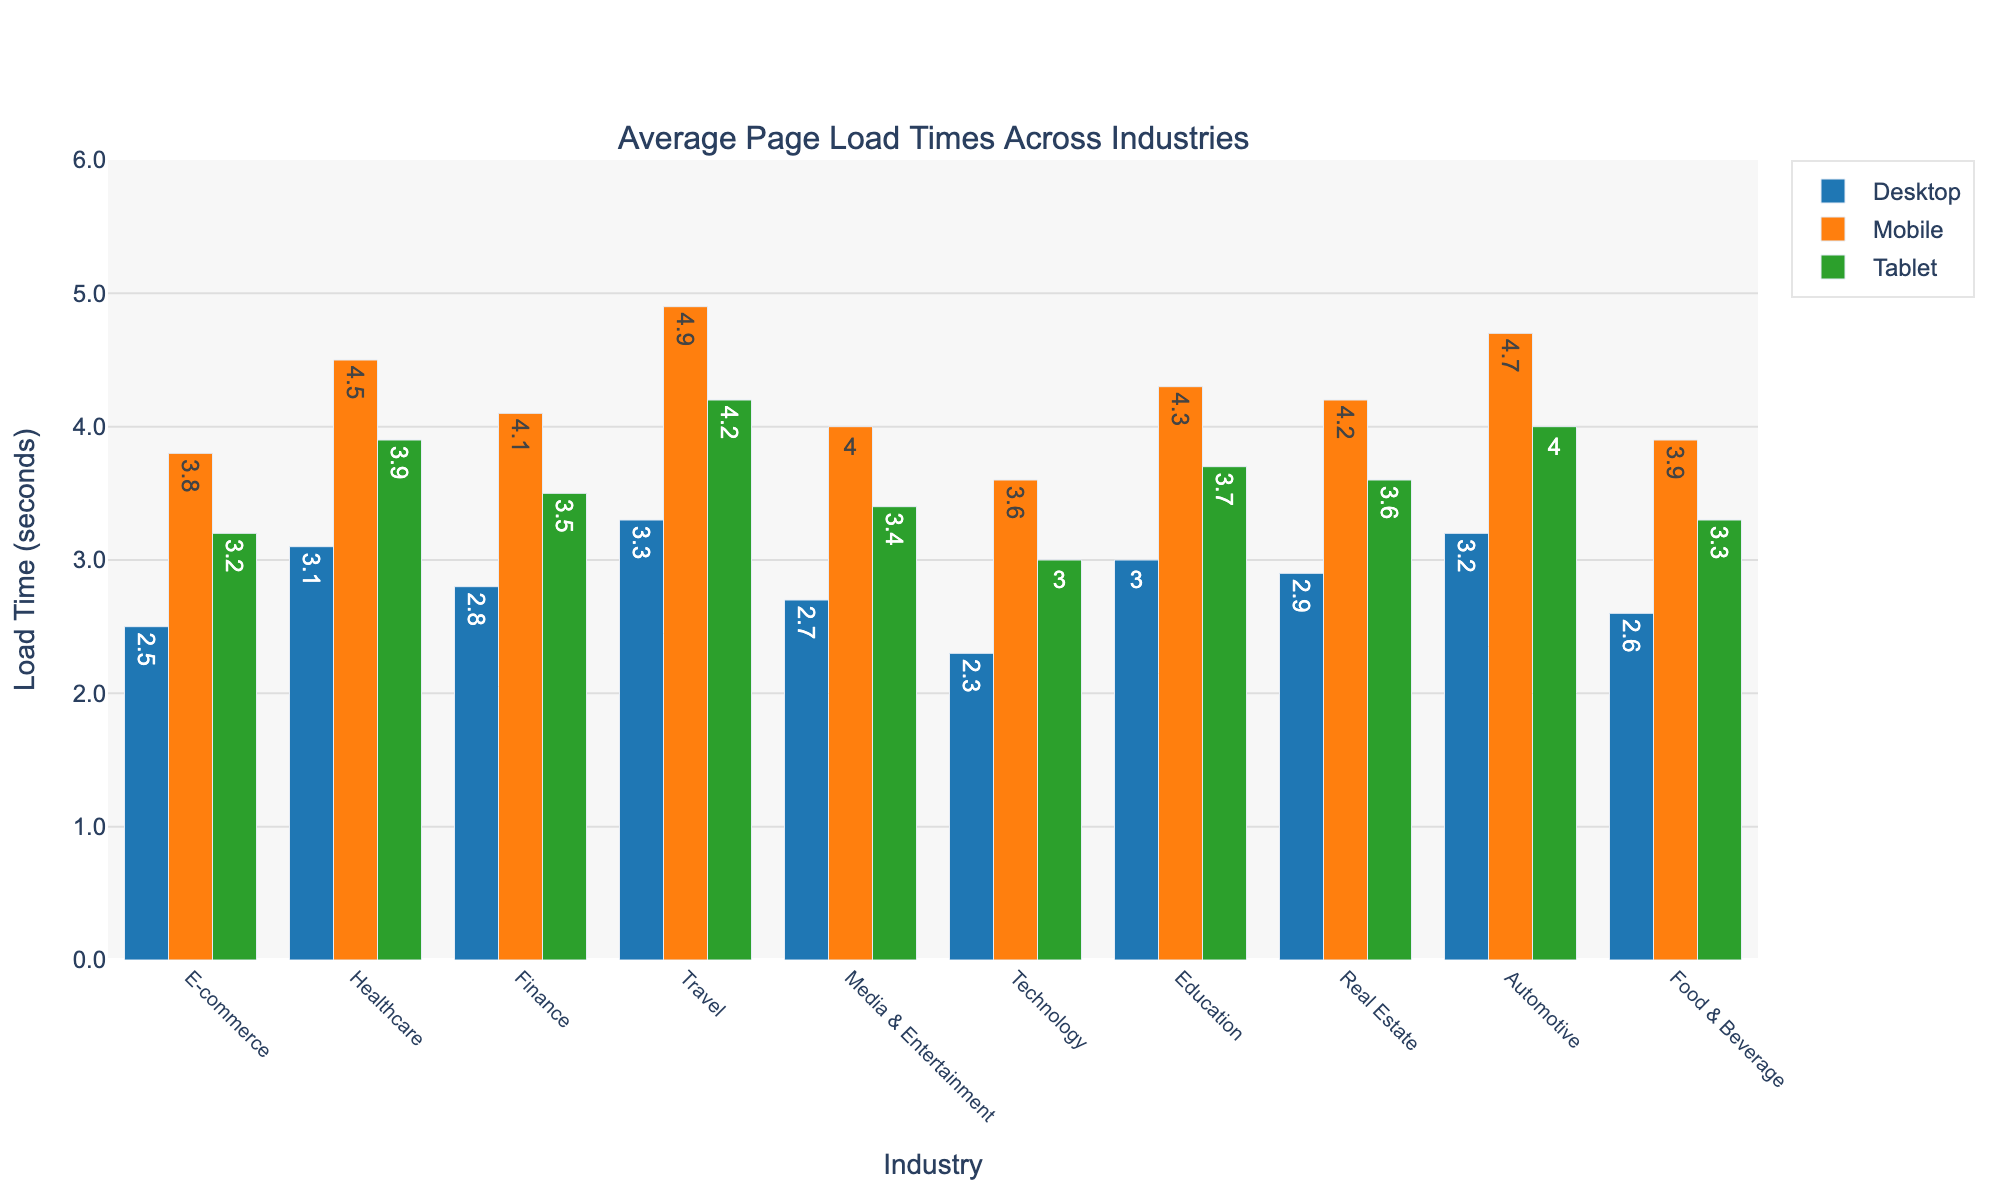What is the average page load time for the E-commerce industry across all device types? Add the load times for desktop (2.5), mobile (3.8), and tablet (3.2) and divide by 3. The average is (2.5 + 3.8 + 3.2) / 3 = 9.5 / 3.
Answer: 3.17 Which industry has the highest load time for mobile devices? Observe the mobile bars in the chart and identify the one with the highest value. The travel industry has the highest mobile load time of 4.9 seconds.
Answer: Travel Compare the page load times of the Healthcare and Education industries for desktop devices. Which one is faster? Look at the desktop load times for both industries: Healthcare is 3.1 seconds, and Education is 3.0 seconds. Education is faster by 0.1 seconds.
Answer: Education Which device type generally has the slowest page load time across industries? Compare the heights of the bars for desktop, mobile, and tablet. Mobile bars are consistently higher across most industries.
Answer: Mobile Calculate the difference in load times between the fastest and slowest industries for tablet devices. Identify the fastest tablet load time (Technology with 3.0 seconds) and the slowest (Travel with 4.2 seconds). The difference is 4.2 - 3.0 = 1.2 seconds.
Answer: 1.2 What are the two industries with load times closest to each other for desktop devices? Compare the desktop load times and identify the two closest values, which are Finance (2.8) and Real Estate (2.9). The difference is 0.1 seconds.
Answer: Finance and Real Estate Which industry has the smallest difference in page load times between tablet and mobile devices? Subtract tablet load times from mobile load times for each industry and find the smallest difference. E-commerce has the smallest difference: 3.8 - 3.2 = 0.6 seconds.
Answer: E-commerce Do any industries have desktop load times that are faster than the fastest mobile load time? The fastest mobile load time is for the Technology industry (3.6 seconds). All desktop load times are faster than 3.6 seconds for the Technology industry (2.3 seconds).
Answer: Yes How much faster is the average page load time for the Technology industry on desktop compared to the Travel industry on mobile? Subtract the Technology desktop load time (2.3) from the Travel mobile load time (4.9). The difference is 4.9 - 2.3 = 2.6 seconds.
Answer: 2.6 Which industry's page load time on a desktop is closest to the average desktop page load time across all industries? Calculate the average desktop load time: (2.5 + 3.1 + 2.8 + 3.3 + 2.7 + 2.3 + 3.0 + 2.9 + 3.2 + 2.6) / 10 = 2.94 seconds. The closest is Finance at 2.8 seconds.
Answer: Finance 